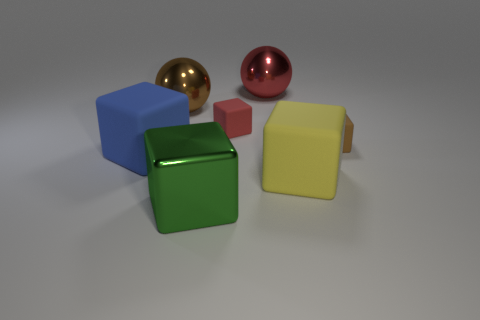Is the number of green shiny objects to the right of the big shiny cube less than the number of small objects on the right side of the big yellow matte cube?
Your answer should be very brief. Yes. The red object that is made of the same material as the yellow cube is what size?
Keep it short and to the point. Small. Is there anything else of the same color as the metallic cube?
Offer a terse response. No. Is the red sphere made of the same material as the tiny block to the right of the red metal thing?
Offer a very short reply. No. What material is the blue thing that is the same shape as the brown matte thing?
Ensure brevity in your answer.  Rubber. Are the red block that is behind the large shiny cube and the brown object left of the red ball made of the same material?
Provide a short and direct response. No. What color is the tiny cube behind the tiny thing to the right of the rubber cube in front of the large blue object?
Offer a very short reply. Red. What number of other objects are there of the same shape as the large red thing?
Your response must be concise. 1. How many things are big blocks or large blocks that are behind the large metallic block?
Offer a terse response. 3. Are there any yellow objects that have the same size as the brown shiny object?
Keep it short and to the point. Yes. 